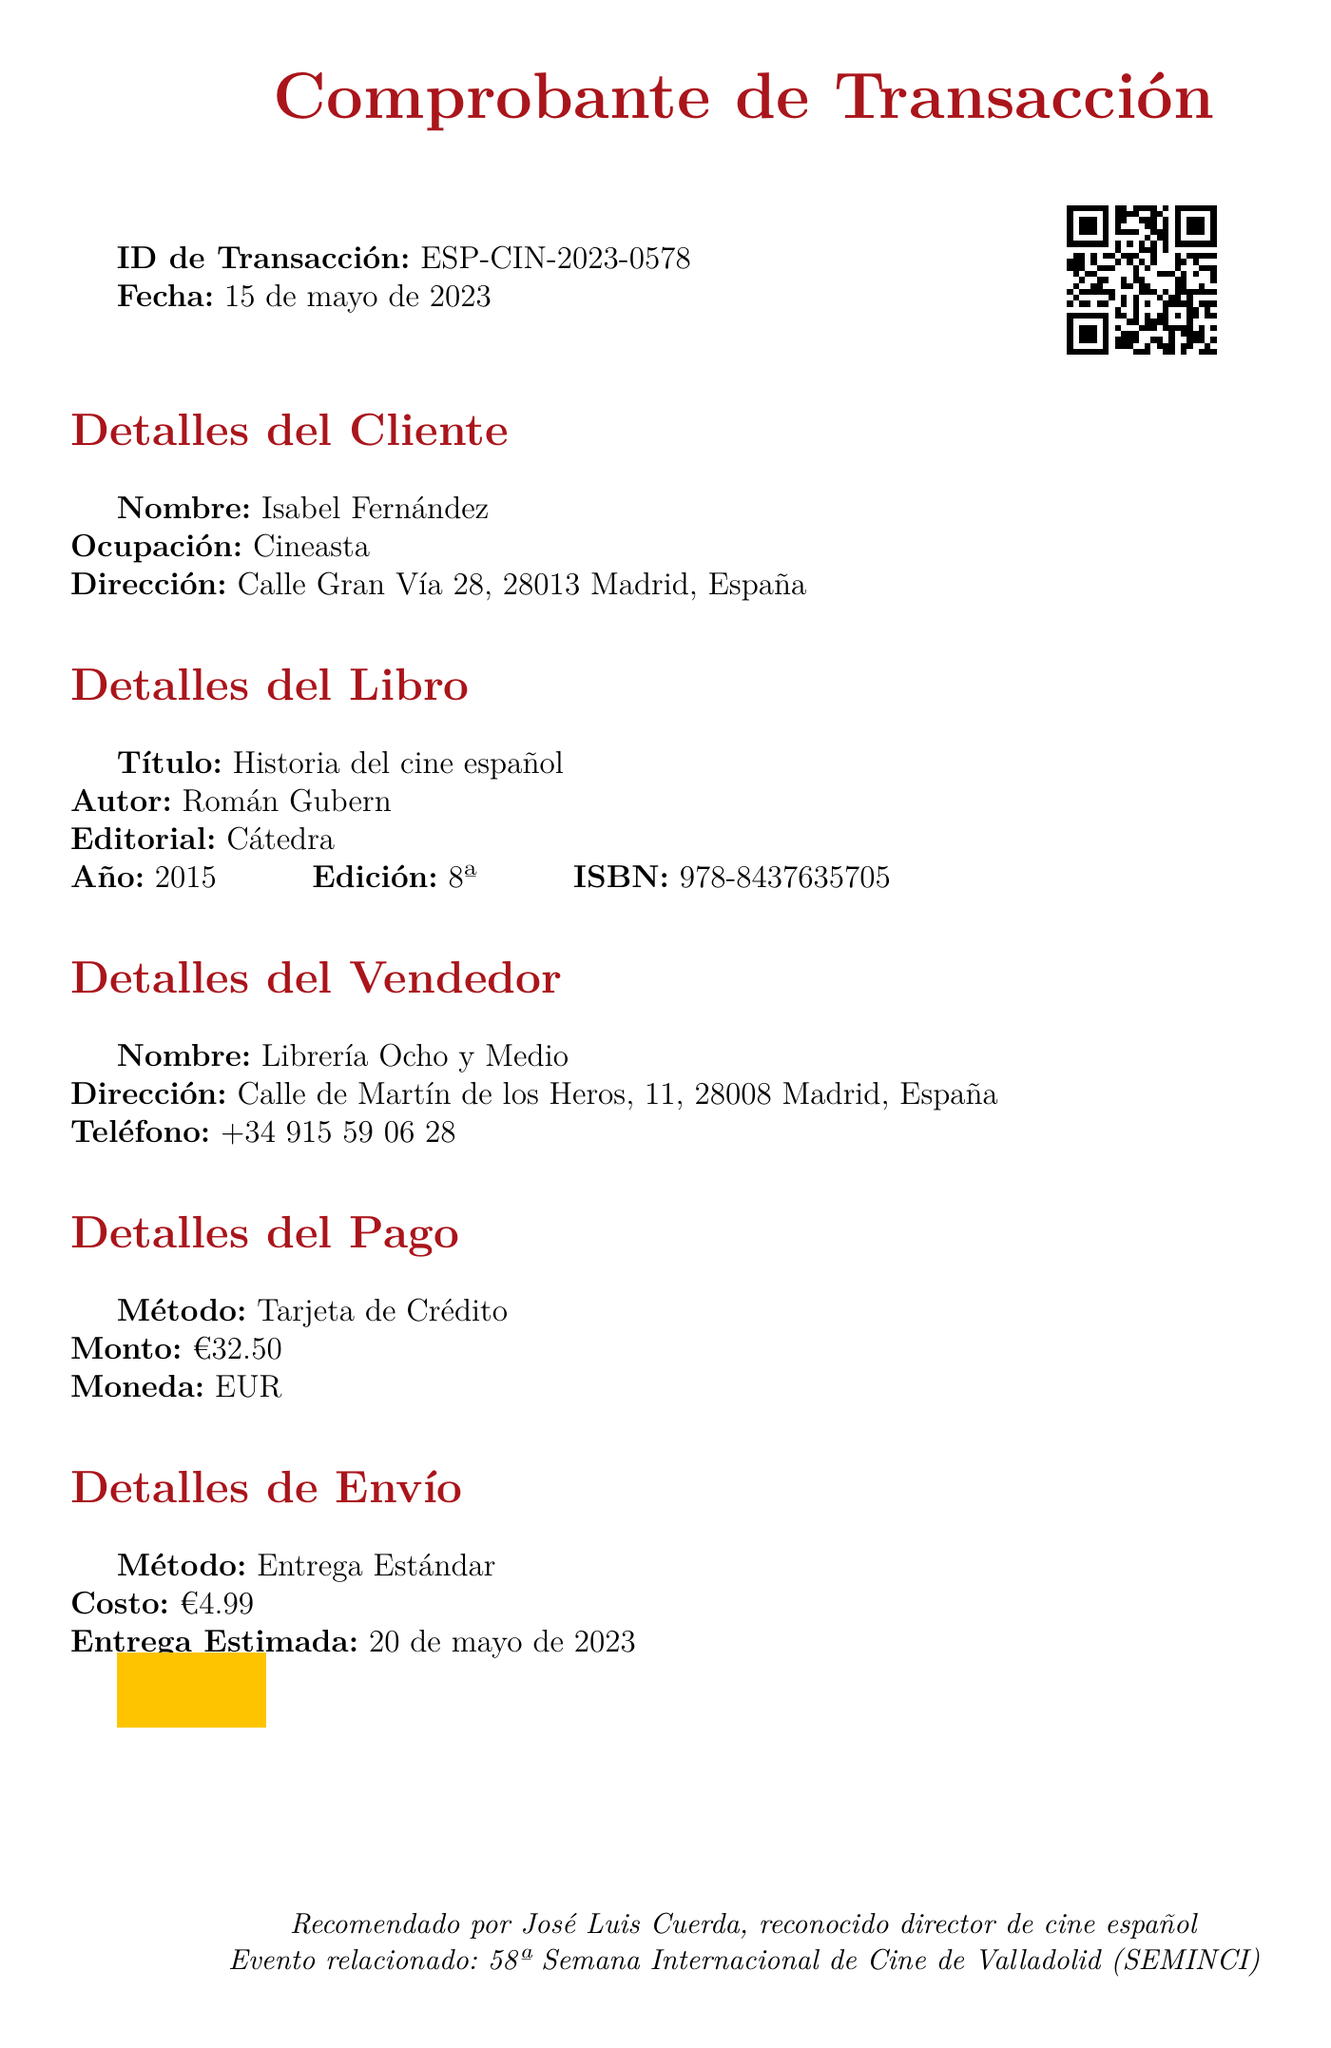what is the title of the book? The title of the book is mentioned in the document under "Detalles del Libro."
Answer: Historia del cine español who is the author of the book? The author's name is specified in the "Detalles del Libro" section.
Answer: Román Gubern what is the publication year of the book? The year is indicated under "Detalles del Libro."
Answer: 2015 what payment method was used for the purchase? The payment method is described in the "Detalles del Pago" section.
Answer: Credit Card what was the total amount paid for the book? The total amount paid is found in the "Detalles del Pago" section.
Answer: €32.50 who recommended the book? The recommendation is noted in the "additional_info" section of the document.
Answer: José Luis Cuerda what is the estimated delivery date? The estimated delivery date can be found in the "Detalles de Envío" section.
Answer: 20 de mayo de 2023 where is the seller located? The seller's address is detailed in the "Detalles del Vendedor" section.
Answer: Calle de Martín de los Heros, 11, 28008 Madrid, España what edition of the book was purchased? The edition of the book is specified in the "Detalles del Libro" section.
Answer: 8ª 